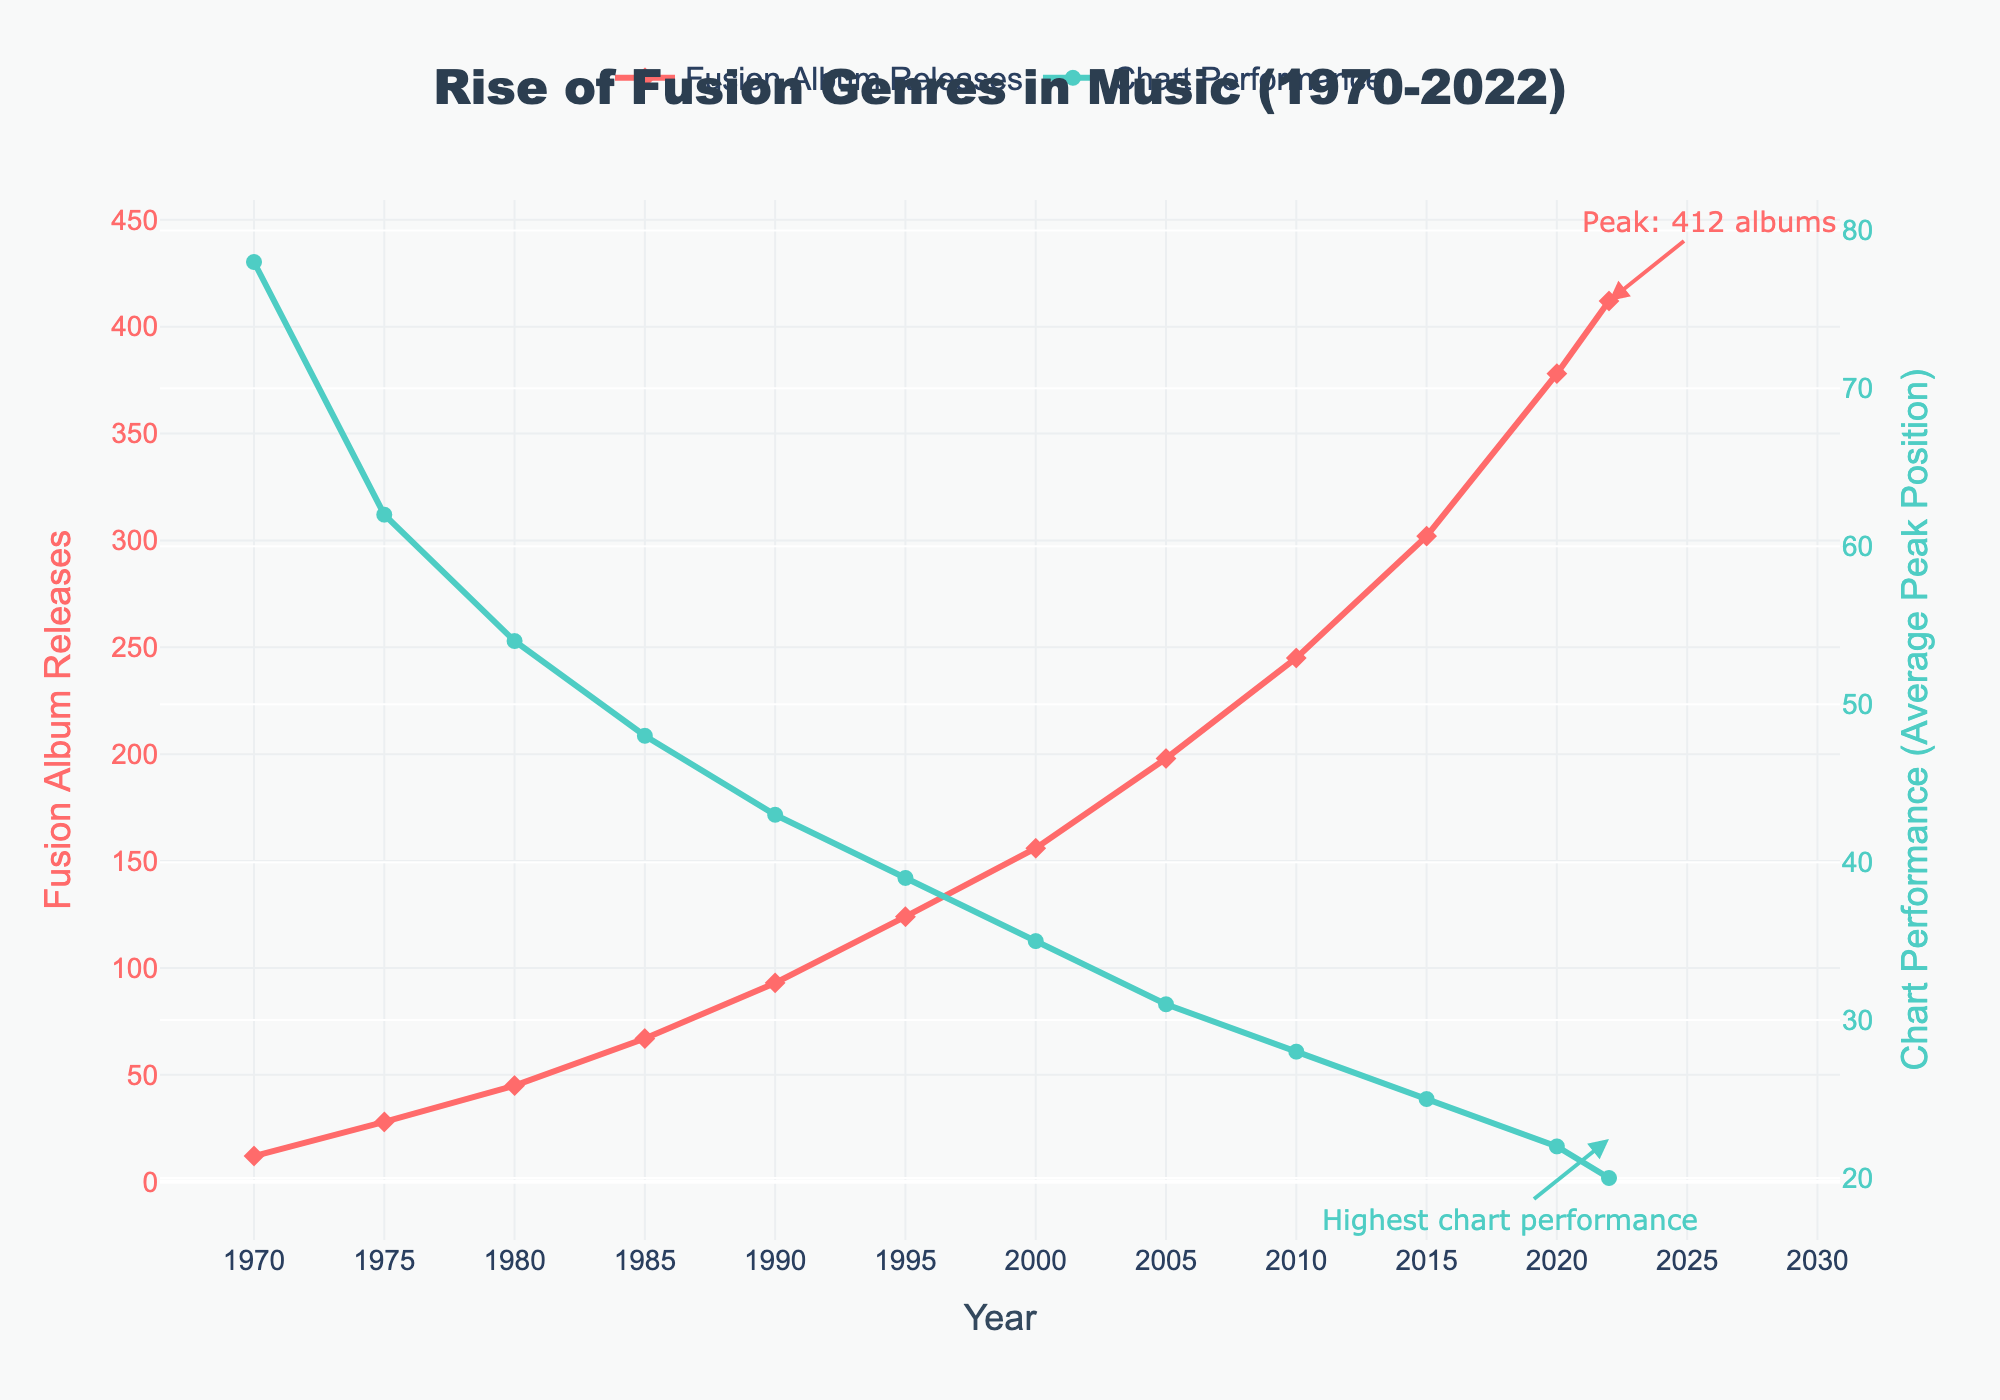How many more fusion album releases were there in 2022 compared to 1985? To find out how many more albums were released in 2022 compared to 1985, subtract the 1985 value from the 2022 value: 412 - 67 = 345.
Answer: 345 Did the average peak position in chart performance improve or worsen from 2010 to 2022? To determine if the performance improved or worsened, compare the average peak positions in 2010 and 2022. Since a lower number indicates a better position, compare 28 (2010) and 20 (2022): 20 is better than 28.
Answer: Improved What is the general trend in the number of fusion album releases from 1970 to 2022? To identify the trend, observe the album releases over time: the numbers increase from 12 in 1970 to 412 in 2022, showing a general upward trend.
Answer: Upward trend During which period did the average peak position in chart performance see the most significant improvement? To find the period with the most significant improvement, compare the changes in average peak positions between consecutive periods. The largest drop occurs between 1975 (62) and 1980 (54) with a 8-point improvement.
Answer: 1975-1980 What are the colors and marker shapes used for the two different metrics in the plot? Identify the visual elements for each metric: Fusion Album Releases are represented by red lines with diamond markers, and Chart Performance is represented by green lines with circle markers.
Answer: Red diamonds and green circles How much did the number of fusion album releases increase between 1990 and 2005? Subtract the number of releases in 1990 from those in 2005: 198 - 93 = 105.
Answer: 105 What year marks the peak for fusion album releases, and how many albums were released? Identify the highest point on the Fusion Album Releases line: the peak is in 2022 with 412 albums.
Answer: 2022, 412 albums By how much did the average peak position improve from 2000 to 2022? Subtract the 2022 average peak position from the 2000 average peak position: 35 - 20 = 15.
Answer: 15 Which metric shows a consistent improvement throughout the entire period shown? Compare the trends of the two metrics: the average peak position consistently improves from 78 in 1970 to 20 in 2022.
Answer: Chart performance What specific annotation indicates the highest number of fusion album releases, and where is it located? Look for the annotation text and its position: "Peak: 412 albums" annotation is placed near the 2022 data point.
Answer: "Peak: 412 albums" near 2022 